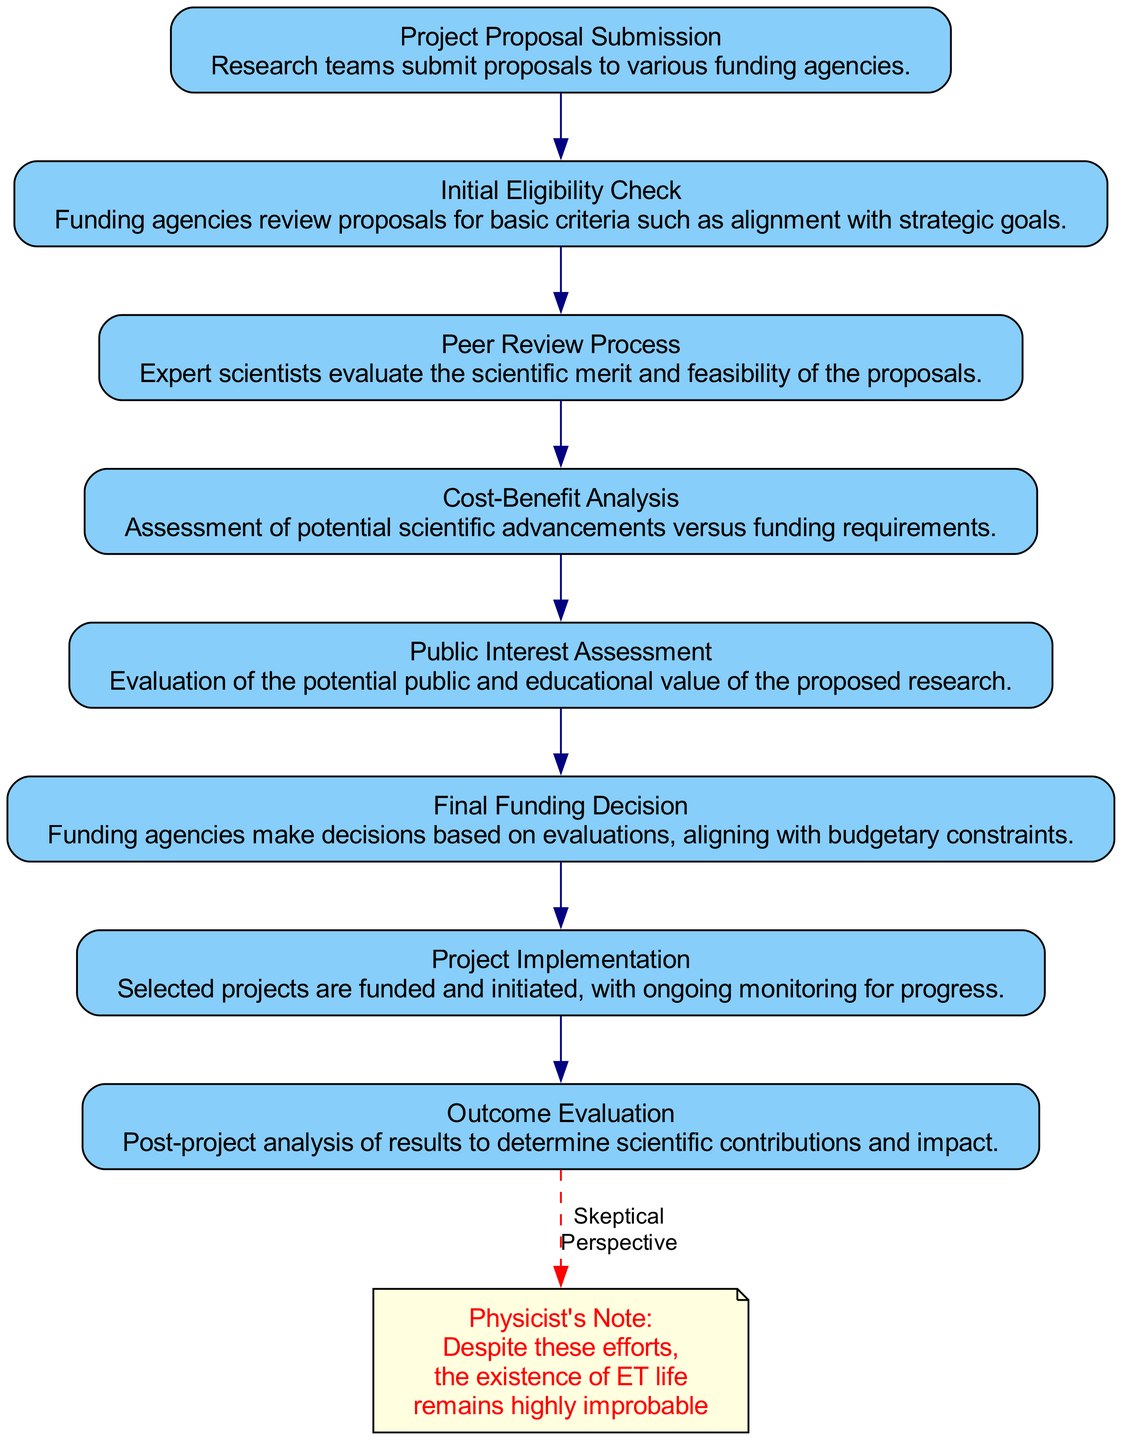What is the first step in the funding decision process? According to the flow chart, the first step is "Project Proposal Submission," where research teams submit proposals to funding agencies.
Answer: Project Proposal Submission What criteria are evaluated after the initial eligibility check? Following the initial eligibility check, the peer review process evaluates the scientific merit and feasibility of the proposals.
Answer: Peer Review Process How many main steps are there in the decision-making process? The flow chart outlines a total of eight main steps in the decision-making process from proposal submission to outcome evaluation.
Answer: Eight What happens after the public interest assessment? After the public interest assessment, the next step is the final funding decision, where funding agencies make decisions based on evaluations and budgetary constraints.
Answer: Final Funding Decision What does the physicist's note emphasize about extraterrestrial life? The physicist's note emphasizes that despite the thorough funding and evaluation process, the existence of extraterrestrial life remains highly improbable.
Answer: Highly improbable In which step do funding agencies conduct a cost-benefit analysis? Funding agencies conduct a cost-benefit analysis after the peer review process to assess potential scientific advancements versus funding requirements.
Answer: Cost-Benefit Analysis What does the outcome evaluation analyze? The outcome evaluation analyzes the results of the selected projects post-implementation to determine their scientific contributions and impact.
Answer: Scientific contributions and impact Which node indicates that selected projects are funded and monitored? The "Project Implementation" node indicates that selected projects are funded and initiated along with ongoing monitoring for progress.
Answer: Project Implementation What type of analysis is performed prior to making the final funding decision? A cost-benefit analysis is performed prior to making the final funding decision to assess the feasibility and potential scientific advancements of the proposals.
Answer: Cost-Benefit Analysis 